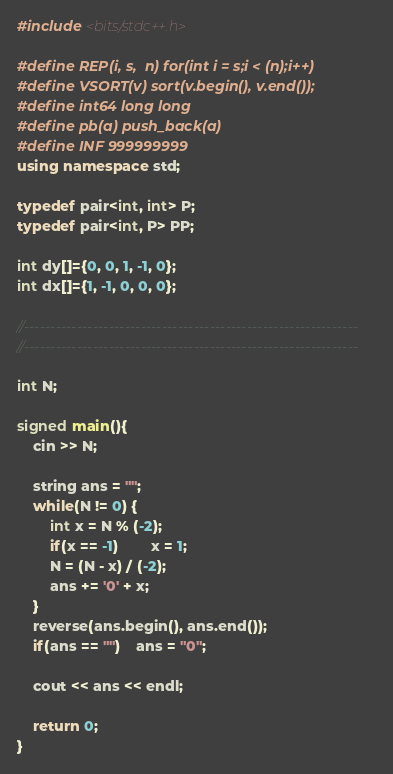<code> <loc_0><loc_0><loc_500><loc_500><_C++_>#include <bits/stdc++.h>

#define REP(i, s,  n) for(int i = s;i < (n);i++)
#define VSORT(v) sort(v.begin(), v.end());
#define int64 long long
#define pb(a) push_back(a)
#define INF 999999999
using namespace std;

typedef pair<int, int> P;
typedef pair<int, P> PP;

int dy[]={0, 0, 1, -1, 0};
int dx[]={1, -1, 0, 0, 0};

//---------------------------------------------------------------
//---------------------------------------------------------------

int N;

signed main(){
	cin >> N;
	
	string ans = "";
	while(N != 0) {
		int x = N % (-2);
		if(x == -1)		x = 1;
		N = (N - x) / (-2);
		ans += '0' + x;
	}
	reverse(ans.begin(), ans.end());
	if(ans == "")	ans = "0";
	
	cout << ans << endl;
	
	return 0;
}
</code> 